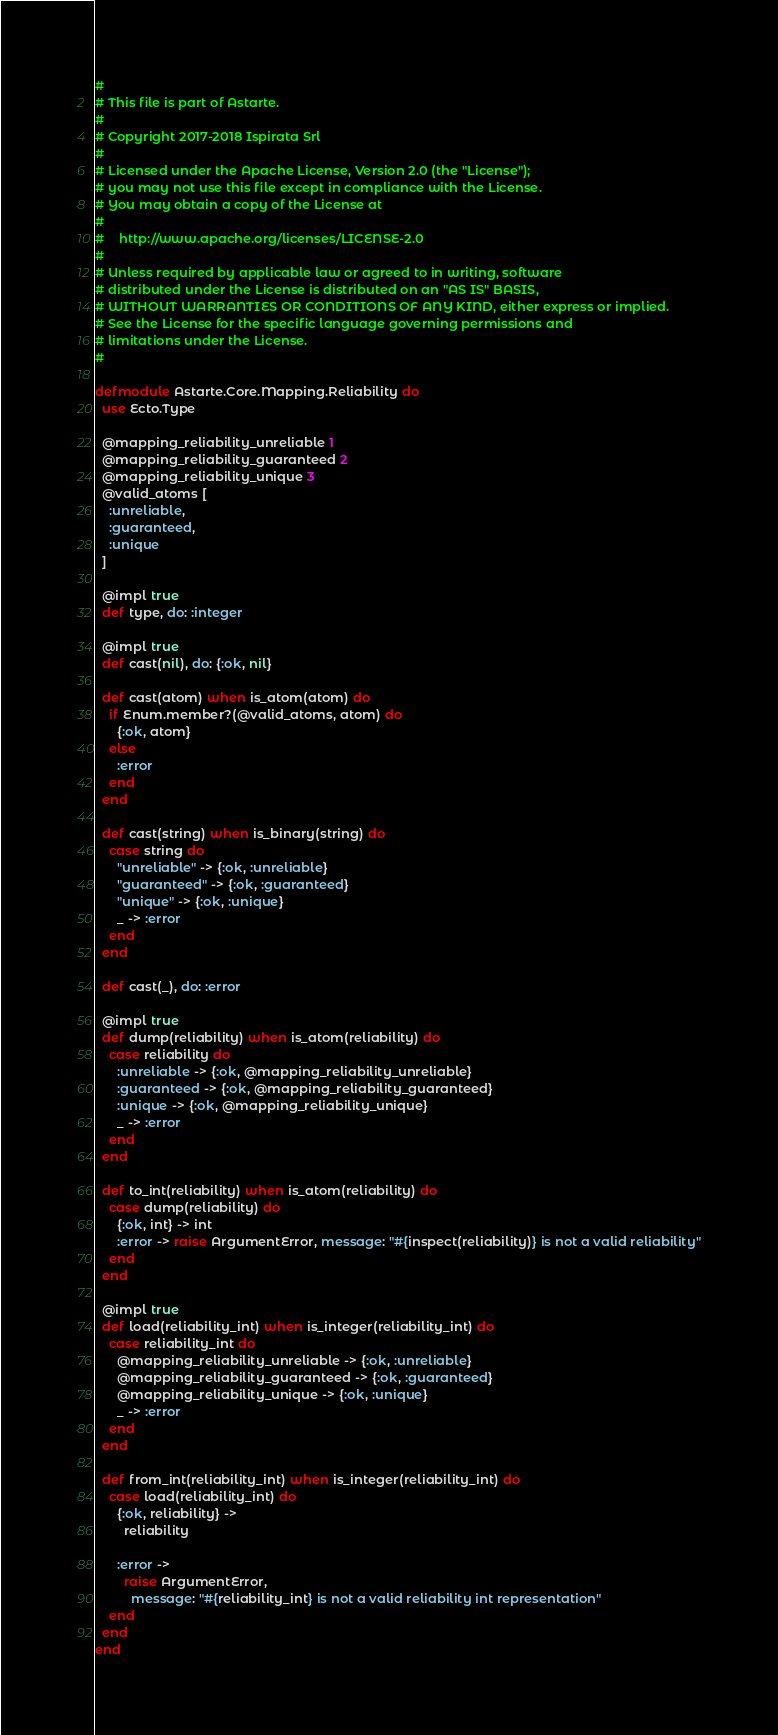Convert code to text. <code><loc_0><loc_0><loc_500><loc_500><_Elixir_>#
# This file is part of Astarte.
#
# Copyright 2017-2018 Ispirata Srl
#
# Licensed under the Apache License, Version 2.0 (the "License");
# you may not use this file except in compliance with the License.
# You may obtain a copy of the License at
#
#    http://www.apache.org/licenses/LICENSE-2.0
#
# Unless required by applicable law or agreed to in writing, software
# distributed under the License is distributed on an "AS IS" BASIS,
# WITHOUT WARRANTIES OR CONDITIONS OF ANY KIND, either express or implied.
# See the License for the specific language governing permissions and
# limitations under the License.
#

defmodule Astarte.Core.Mapping.Reliability do
  use Ecto.Type

  @mapping_reliability_unreliable 1
  @mapping_reliability_guaranteed 2
  @mapping_reliability_unique 3
  @valid_atoms [
    :unreliable,
    :guaranteed,
    :unique
  ]

  @impl true
  def type, do: :integer

  @impl true
  def cast(nil), do: {:ok, nil}

  def cast(atom) when is_atom(atom) do
    if Enum.member?(@valid_atoms, atom) do
      {:ok, atom}
    else
      :error
    end
  end

  def cast(string) when is_binary(string) do
    case string do
      "unreliable" -> {:ok, :unreliable}
      "guaranteed" -> {:ok, :guaranteed}
      "unique" -> {:ok, :unique}
      _ -> :error
    end
  end

  def cast(_), do: :error

  @impl true
  def dump(reliability) when is_atom(reliability) do
    case reliability do
      :unreliable -> {:ok, @mapping_reliability_unreliable}
      :guaranteed -> {:ok, @mapping_reliability_guaranteed}
      :unique -> {:ok, @mapping_reliability_unique}
      _ -> :error
    end
  end

  def to_int(reliability) when is_atom(reliability) do
    case dump(reliability) do
      {:ok, int} -> int
      :error -> raise ArgumentError, message: "#{inspect(reliability)} is not a valid reliability"
    end
  end

  @impl true
  def load(reliability_int) when is_integer(reliability_int) do
    case reliability_int do
      @mapping_reliability_unreliable -> {:ok, :unreliable}
      @mapping_reliability_guaranteed -> {:ok, :guaranteed}
      @mapping_reliability_unique -> {:ok, :unique}
      _ -> :error
    end
  end

  def from_int(reliability_int) when is_integer(reliability_int) do
    case load(reliability_int) do
      {:ok, reliability} ->
        reliability

      :error ->
        raise ArgumentError,
          message: "#{reliability_int} is not a valid reliability int representation"
    end
  end
end
</code> 